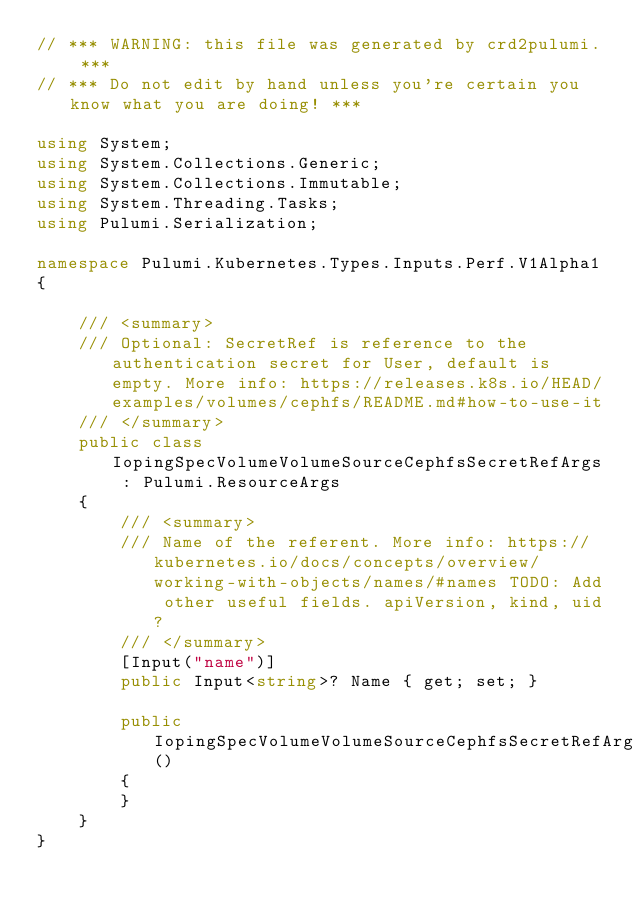Convert code to text. <code><loc_0><loc_0><loc_500><loc_500><_C#_>// *** WARNING: this file was generated by crd2pulumi. ***
// *** Do not edit by hand unless you're certain you know what you are doing! ***

using System;
using System.Collections.Generic;
using System.Collections.Immutable;
using System.Threading.Tasks;
using Pulumi.Serialization;

namespace Pulumi.Kubernetes.Types.Inputs.Perf.V1Alpha1
{

    /// <summary>
    /// Optional: SecretRef is reference to the authentication secret for User, default is empty. More info: https://releases.k8s.io/HEAD/examples/volumes/cephfs/README.md#how-to-use-it
    /// </summary>
    public class IopingSpecVolumeVolumeSourceCephfsSecretRefArgs : Pulumi.ResourceArgs
    {
        /// <summary>
        /// Name of the referent. More info: https://kubernetes.io/docs/concepts/overview/working-with-objects/names/#names TODO: Add other useful fields. apiVersion, kind, uid?
        /// </summary>
        [Input("name")]
        public Input<string>? Name { get; set; }

        public IopingSpecVolumeVolumeSourceCephfsSecretRefArgs()
        {
        }
    }
}
</code> 